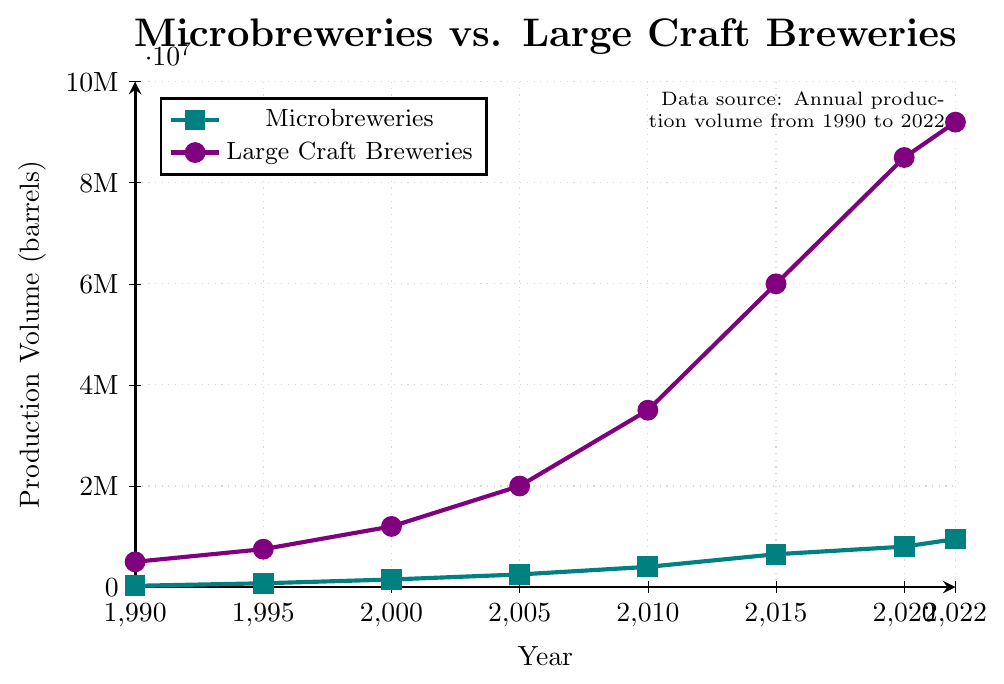What is the difference in production volume between microbreweries and large craft breweries in 1990? The production volume for microbreweries in 1990 is 25,000 barrels, and for large craft breweries, it is 500,000 barrels. The difference is calculated as 500,000 - 25,000.
Answer: 475,000 By how much did the production volume for microbreweries increase from 1990 to 2022? The production volume in 1990 was 25,000 barrels, increasing to 950,000 barrels in 2022. The increase is calculated as 950,000 - 25,000.
Answer: 925,000 In which year did large craft breweries surpass a production volume of 2 million barrels? Referring to the chart, large craft breweries surpassed 2 million barrels in the year 2005.
Answer: 2005 How many years did it take for microbreweries to reach half a million barrels in production volume? Microbreweries reached 500,000 barrels in between 2005 and 2010. They had 250,000 barrels in 2005 and 400,000 barrels in 2010.
Answer: 20 What is the average production volume of microbreweries over the recorded years? The production volumes for microbreweries are 25,000; 75,000; 150,000; 250,000; 400,000; 650,000; 800,000; 950,000. The average is the sum of these values divided by the number of years. (25,000 + 75,000 + 150,000 + 250,000 + 400,000 + 650,000 + 800,000 + 950,000) / 8 = 400,000
Answer: 400,000 What color represents large craft breweries in the plot? Referring to the legend, the large craft breweries are represented by a purple line with circular markers.
Answer: purple Which type of breweries had a steeper increase in production volume between 2010 and 2015? Between 2010 and 2015, microbreweries increased from 400,000 to 650,000 barrels, an increase of 250,000 barrels. Large craft breweries increased from 3,500,000 to 6,000,000 barrels, an increase of 2,500,000 barrels. Large craft breweries had a steeper increase.
Answer: large craft breweries In which year did the production volume of both brewery types increase the most compared to the previous recorded year? For microbreweries, the largest annual increase is from 2010 to 2015 (250,000 barrels). For large craft breweries, the largest annual increase is from 2010 to 2015 (2,500,000 barrels).
Answer: 2015 